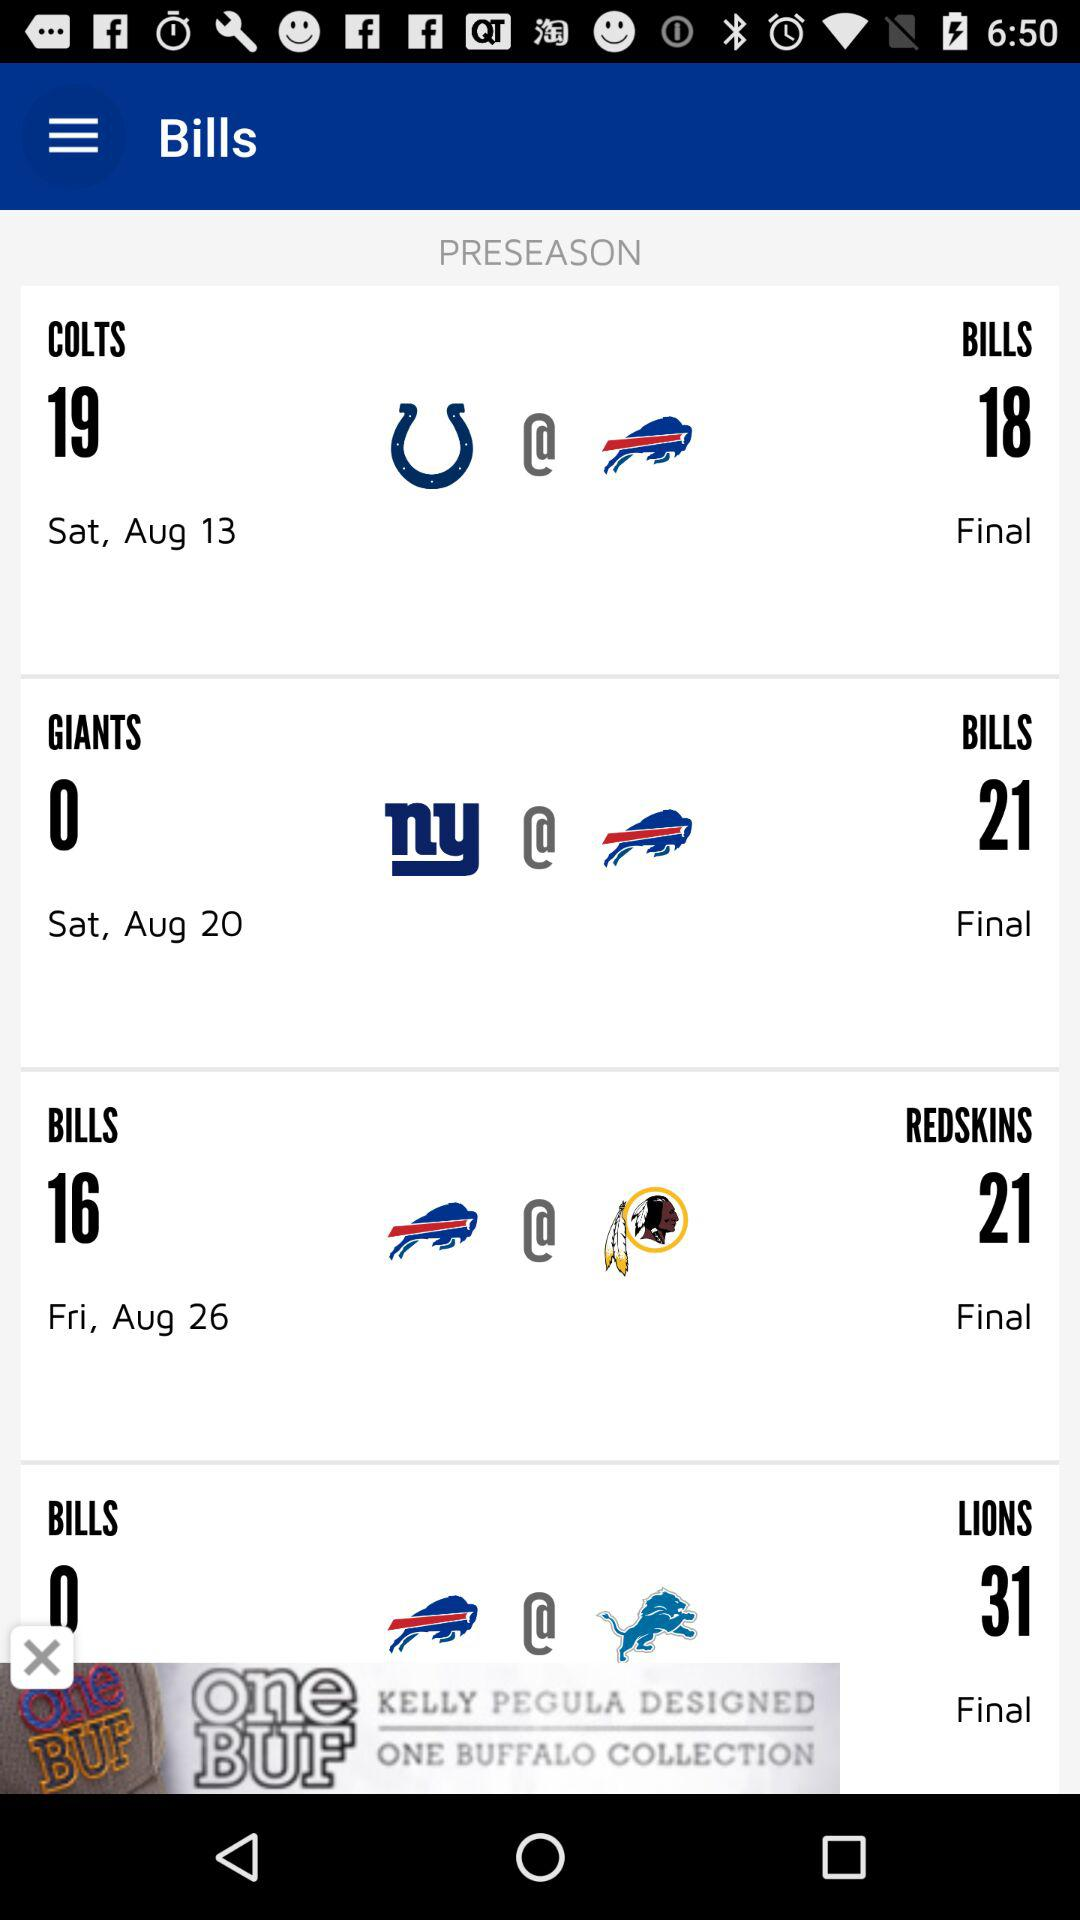What is the date of the final match between the Bills and Redskins? The date is Friday, August 26. 